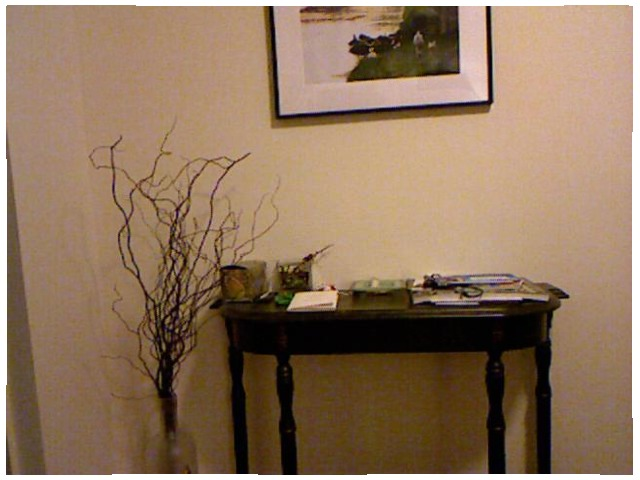<image>
Is there a table under the photo frame? Yes. The table is positioned underneath the photo frame, with the photo frame above it in the vertical space. 